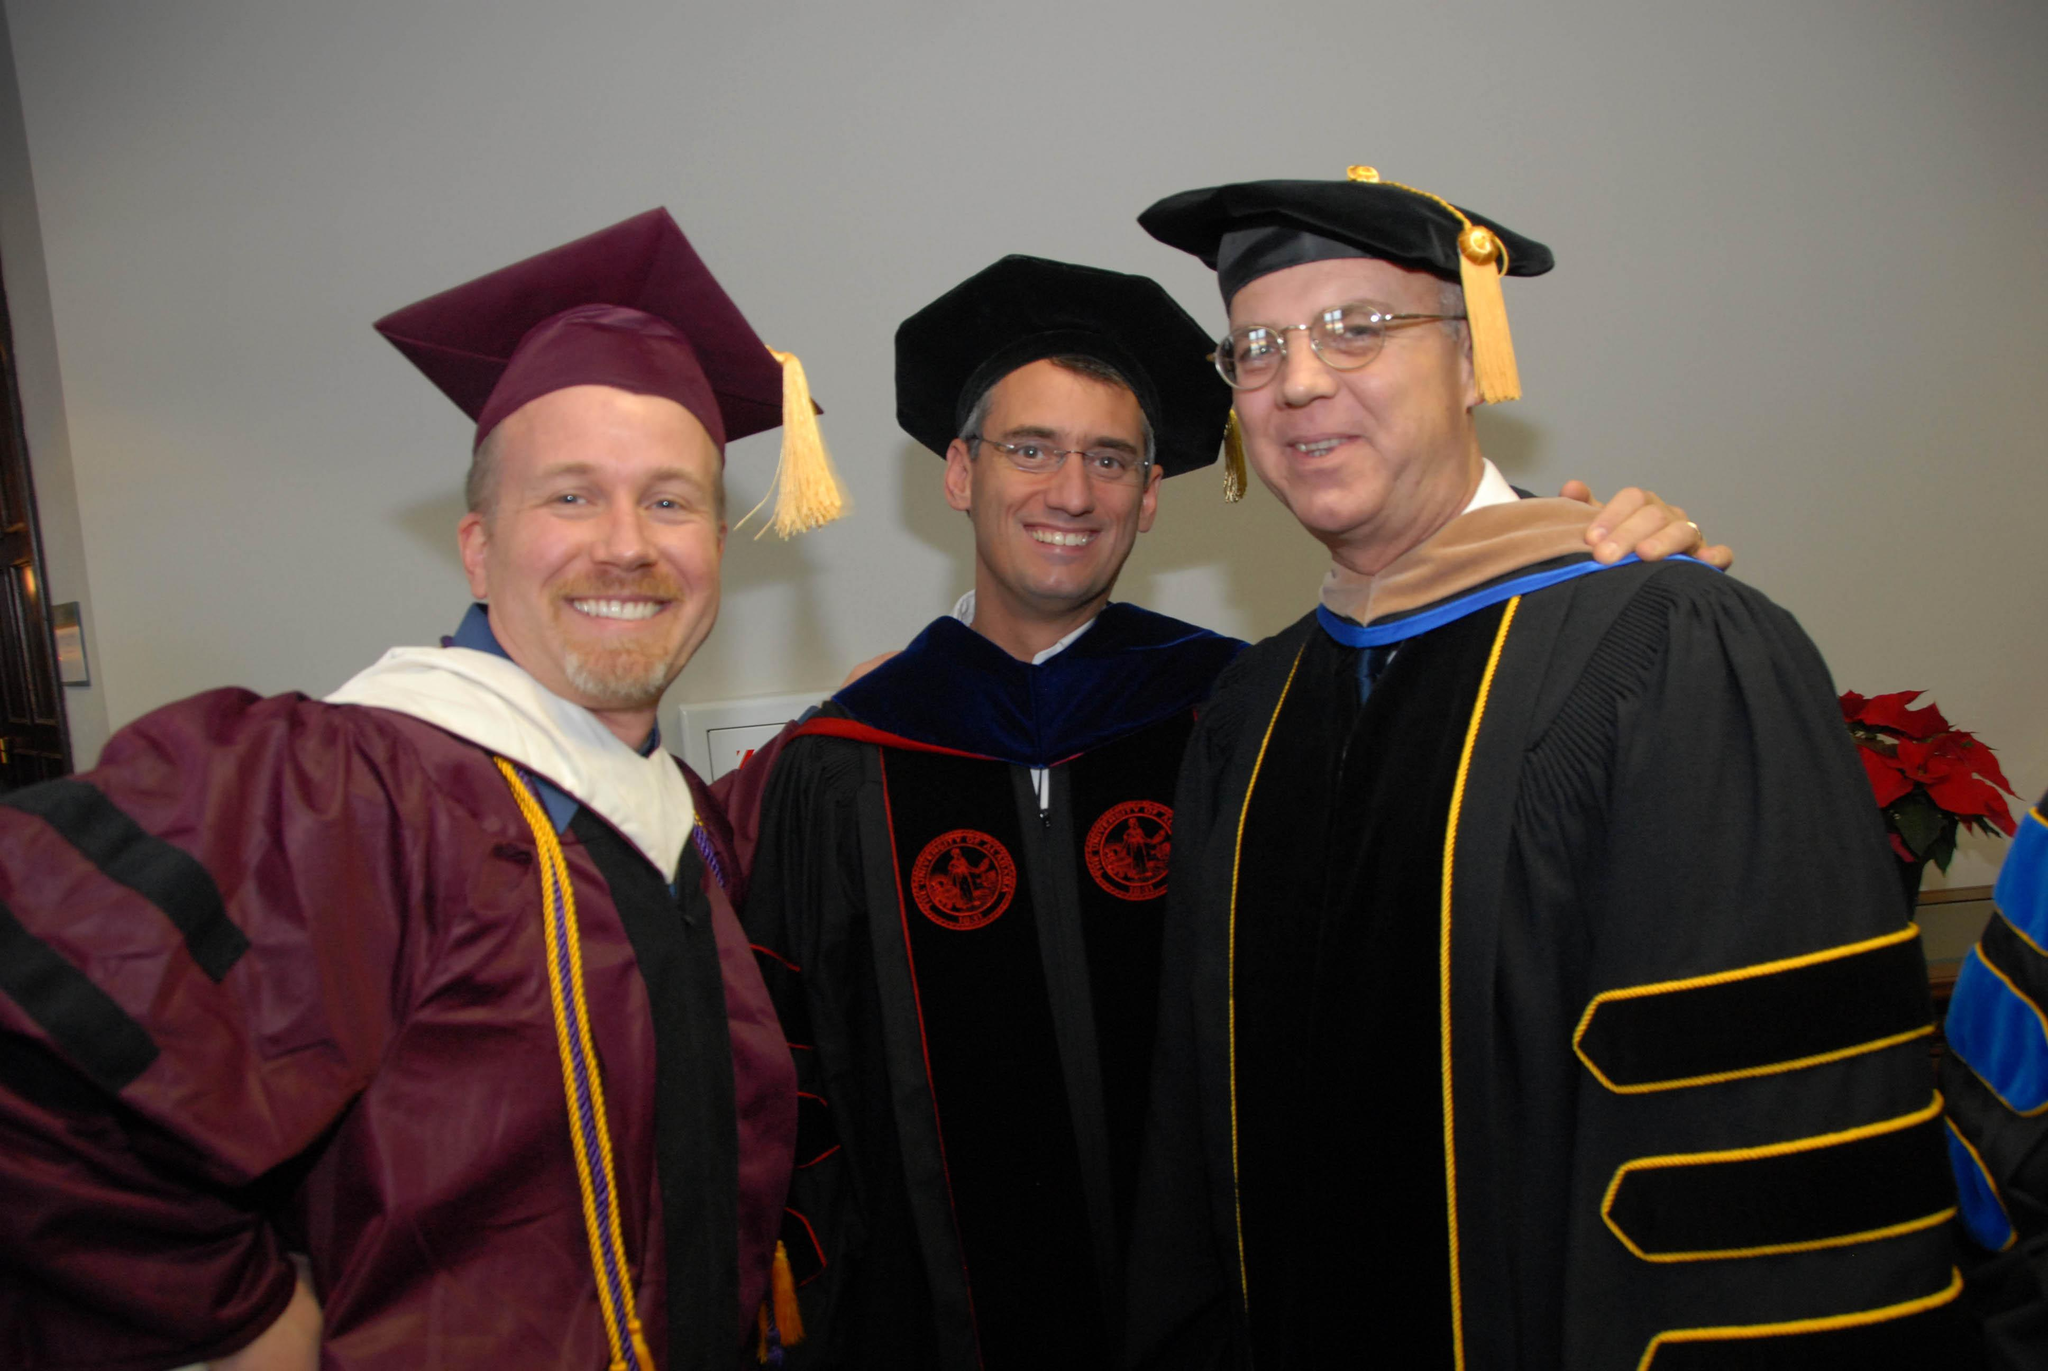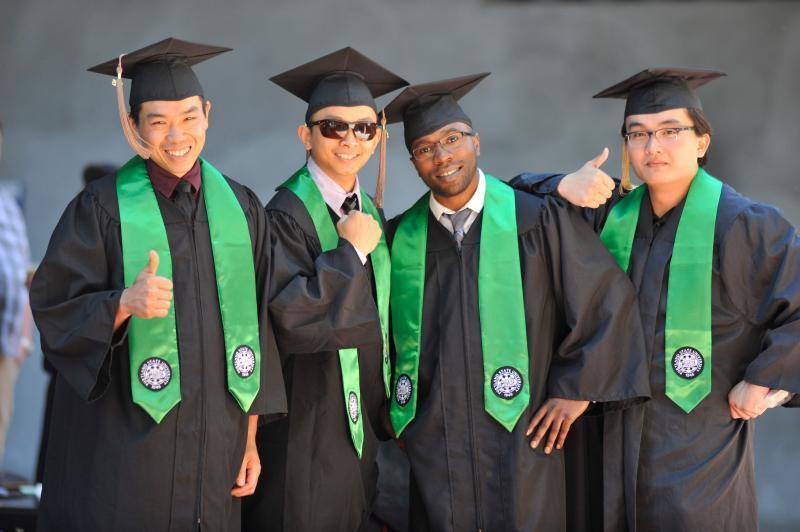The first image is the image on the left, the second image is the image on the right. Considering the images on both sides, is "The grads are wearing green around their necks." valid? Answer yes or no. Yes. The first image is the image on the left, the second image is the image on the right. Given the left and right images, does the statement "There are 2 people wearing graduation caps in the image on the right." hold true? Answer yes or no. No. 